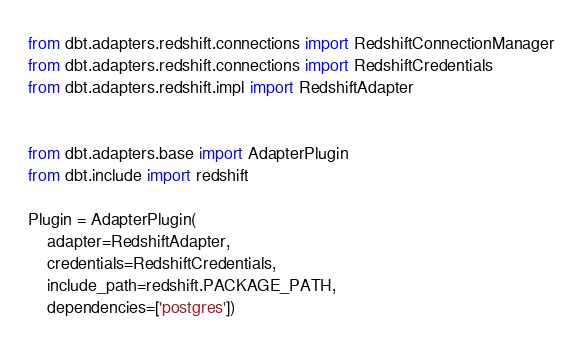<code> <loc_0><loc_0><loc_500><loc_500><_Python_>from dbt.adapters.redshift.connections import RedshiftConnectionManager
from dbt.adapters.redshift.connections import RedshiftCredentials
from dbt.adapters.redshift.impl import RedshiftAdapter


from dbt.adapters.base import AdapterPlugin
from dbt.include import redshift

Plugin = AdapterPlugin(
    adapter=RedshiftAdapter,
    credentials=RedshiftCredentials,
    include_path=redshift.PACKAGE_PATH,
    dependencies=['postgres'])
</code> 